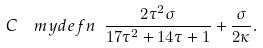<formula> <loc_0><loc_0><loc_500><loc_500>C \ \ m y d e f n \ \frac { 2 \tau ^ { 2 } \sigma } { 1 7 \tau ^ { 2 } + 1 4 \tau + 1 } + \frac { \sigma } { 2 \kappa } .</formula> 